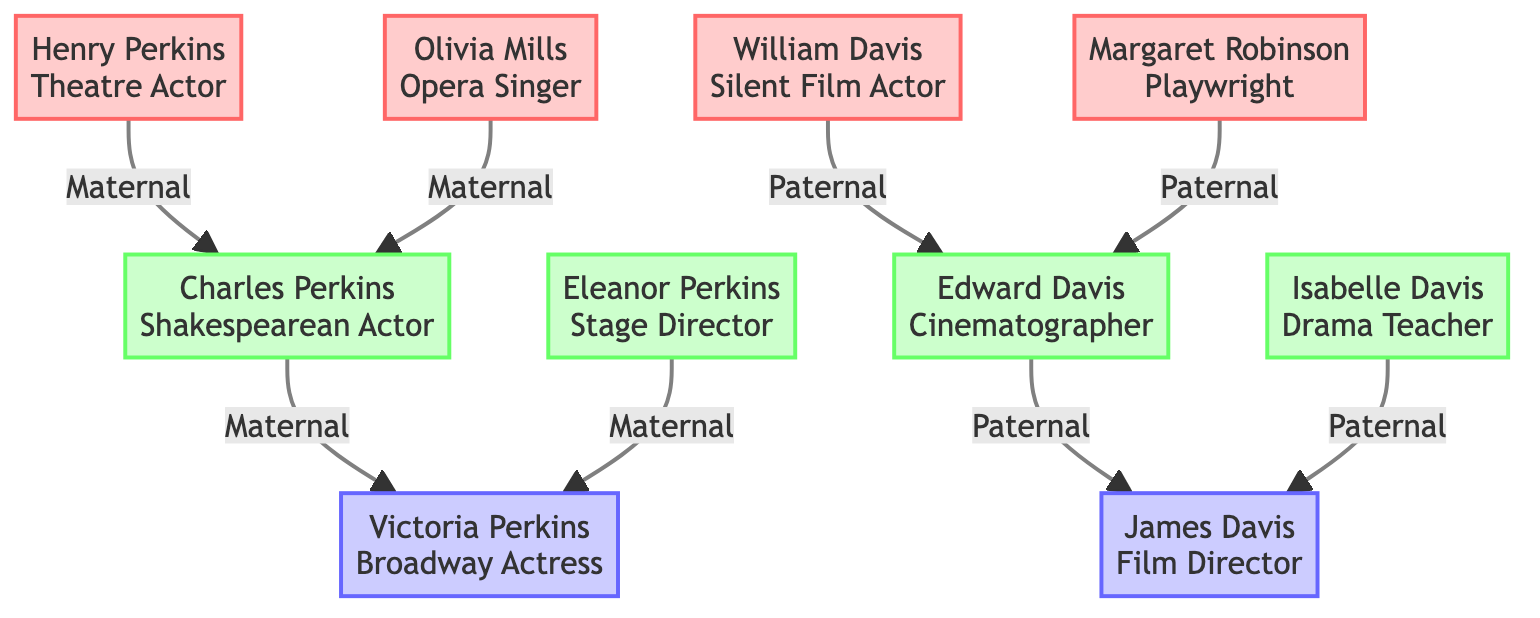What occupation did Henry Perkins have? The diagram shows that Henry Perkins was a Theatre Actor, which is explicitly noted under his name in the node.
Answer: Theatre Actor Who is the maternal great-grandmother? In the diagram, the maternal great-grandmother is identified as Olivia Mills, which is located directly under the maternal great-grandparents section.
Answer: Olivia Mills How many great-grandparents are depicted on the paternal side? The diagram presents two paternal great-grandparents: William Davis and Margaret Robinson, both found in the paternal great-grandparents section.
Answer: 2 What influence did Isabelle Davis have on James Davis? The diagram connects Isabelle Davis to James Davis and notes her influence as fostering foundational acting skills and techniques, showcasing the direct relationship.
Answer: Foundational acting skills Which ancestor was a Silent Film Actor? The diagram clearly identifies William Davis as the Silent Film Actor under the paternal great-grandfather's node.
Answer: William Davis What influence did Eleanor Perkins provide? Eleanor Perkins is connected to Victoria Perkins and is noted for providing insight into the holistic nature of theatre production, indicating her supportive educational role.
Answer: Holistic nature of theatre production Who is the only ancestor in the last generation? The last generation, which is the parents' generation, includes Victoria Perkins and James Davis, but the question refers to the singular parental role, which indicates only one. Here, either could be valid, but Victoria Perkins is the first mentioned.
Answer: Victoria Perkins How are Charles Perkins and Eleanor Perkins related? The diagram shows a direct connection where Charles Perkins is the husband of Eleanor Perkins, solidifying their relation as grandparents to Victoria Perkins.
Answer: Husband and wife What type of actor was Charles Perkins? The diagram specifically categorizes Charles Perkins as a Shakespearean Actor under the grandparents' generation.
Answer: Shakespearean Actor 